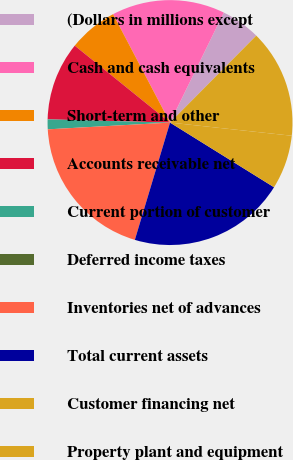Convert chart to OTSL. <chart><loc_0><loc_0><loc_500><loc_500><pie_chart><fcel>(Dollars in millions except<fcel>Cash and cash equivalents<fcel>Short-term and other<fcel>Accounts receivable net<fcel>Current portion of customer<fcel>Deferred income taxes<fcel>Inventories net of advances<fcel>Total current assets<fcel>Customer financing net<fcel>Property plant and equipment<nl><fcel>5.2%<fcel>14.93%<fcel>6.49%<fcel>10.39%<fcel>1.3%<fcel>0.0%<fcel>19.48%<fcel>20.78%<fcel>7.14%<fcel>14.28%<nl></chart> 